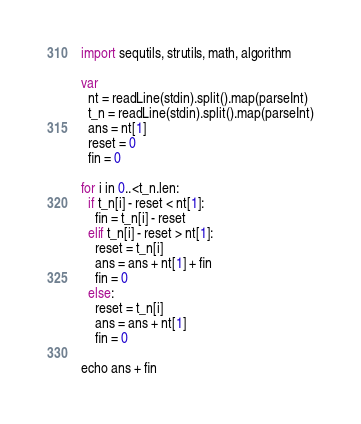Convert code to text. <code><loc_0><loc_0><loc_500><loc_500><_Nim_>import sequtils, strutils, math, algorithm

var
  nt = readLine(stdin).split().map(parseInt)
  t_n = readLine(stdin).split().map(parseInt)
  ans = nt[1]
  reset = 0
  fin = 0

for i in 0..<t_n.len:
  if t_n[i] - reset < nt[1]:
    fin = t_n[i] - reset
  elif t_n[i] - reset > nt[1]:
    reset = t_n[i]
    ans = ans + nt[1] + fin
    fin = 0
  else:
    reset = t_n[i]
    ans = ans + nt[1]
    fin = 0

echo ans + fin</code> 